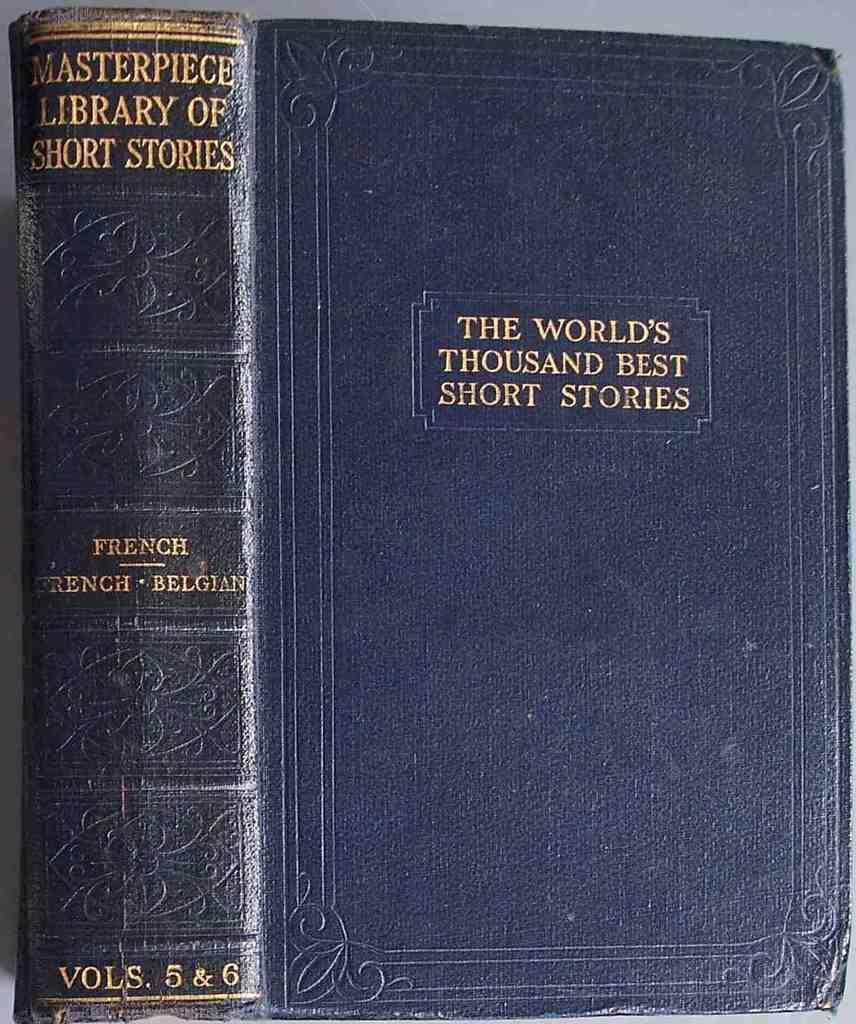<image>
Share a concise interpretation of the image provided. Blue Book titled "The World's Thousand Best Short Stories". 